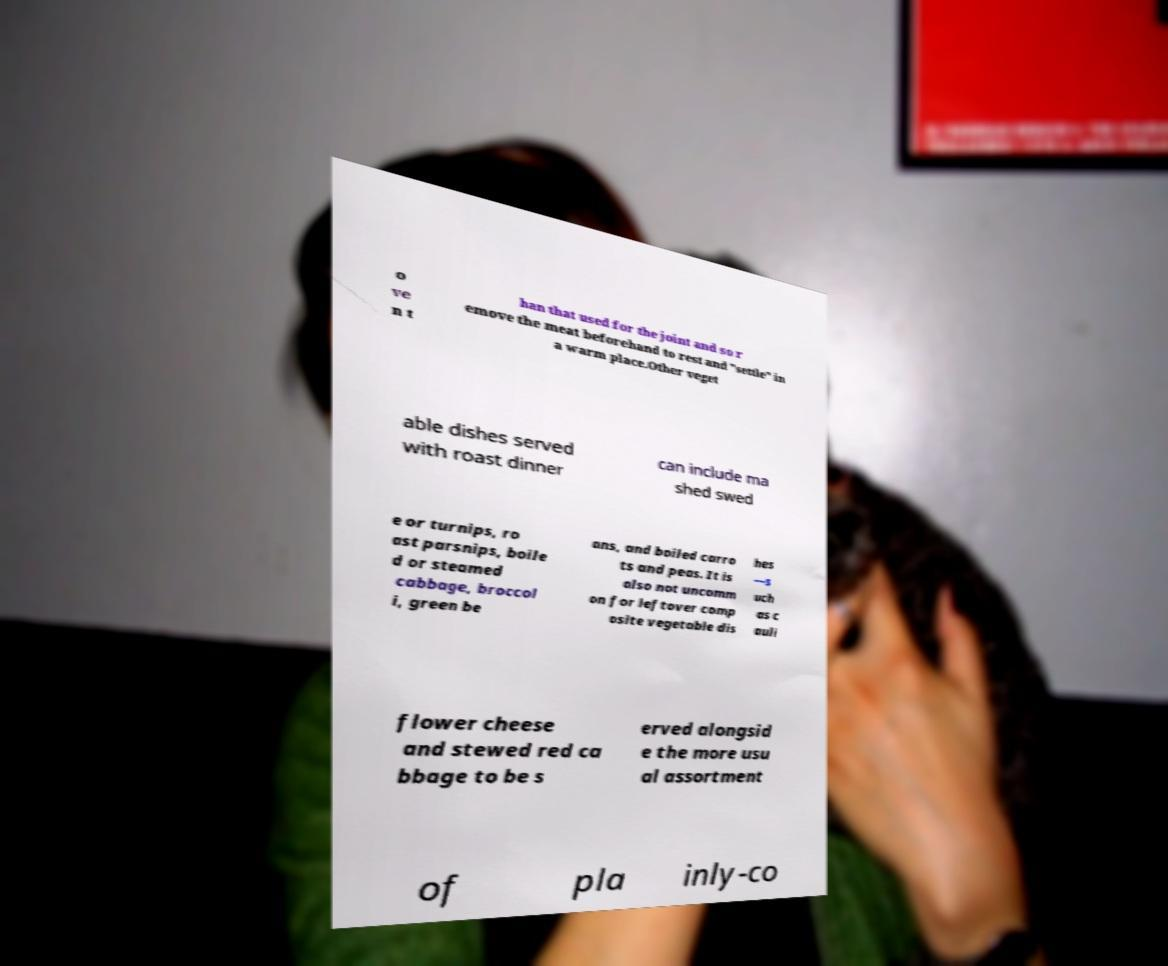Please read and relay the text visible in this image. What does it say? o ve n t han that used for the joint and so r emove the meat beforehand to rest and "settle" in a warm place.Other veget able dishes served with roast dinner can include ma shed swed e or turnips, ro ast parsnips, boile d or steamed cabbage, broccol i, green be ans, and boiled carro ts and peas. It is also not uncomm on for leftover comp osite vegetable dis hes —s uch as c auli flower cheese and stewed red ca bbage to be s erved alongsid e the more usu al assortment of pla inly-co 